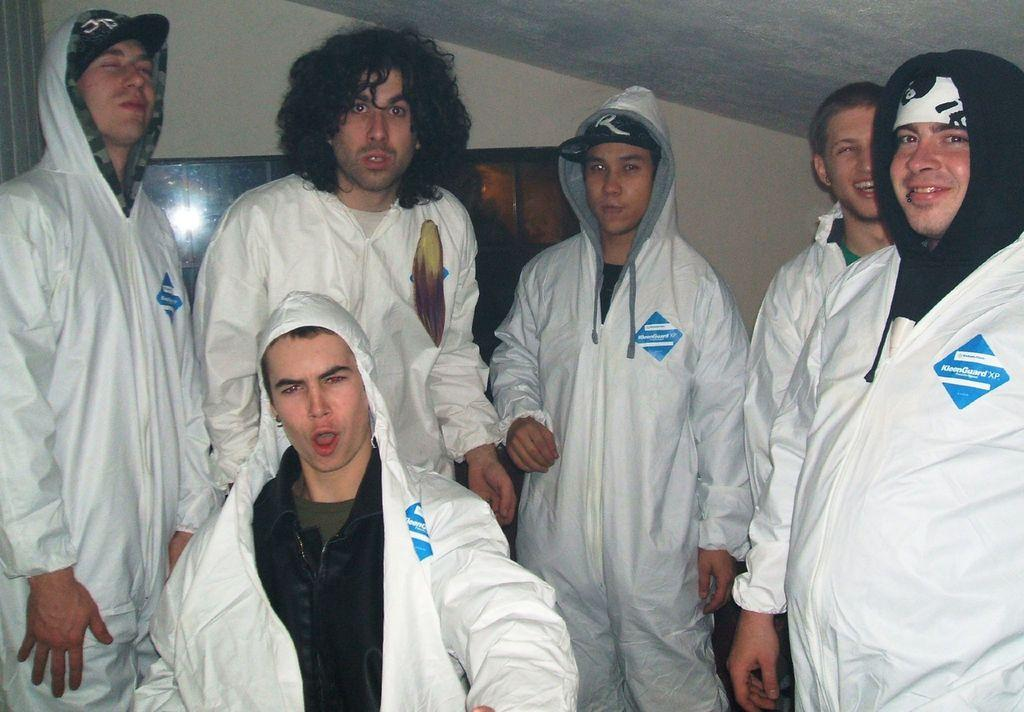<image>
Give a short and clear explanation of the subsequent image. Several men in KleenGuard outfits pose for a photo. 